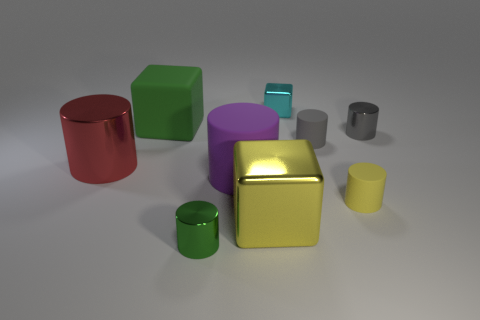Are there the same number of tiny rubber cylinders on the left side of the small yellow rubber cylinder and yellow objects?
Keep it short and to the point. No. What number of other objects are there of the same shape as the big purple matte thing?
Provide a short and direct response. 5. There is a tiny yellow cylinder; what number of big cylinders are right of it?
Your answer should be compact. 0. How big is the matte object that is both in front of the big red thing and to the left of the cyan metal block?
Offer a very short reply. Large. Are there any tiny green balls?
Your answer should be compact. No. What number of other things are there of the same size as the yellow matte cylinder?
Provide a succinct answer. 4. Is the color of the large metal thing behind the yellow shiny thing the same as the metallic thing that is in front of the big metal cube?
Ensure brevity in your answer.  No. There is a gray matte thing that is the same shape as the large purple object; what is its size?
Offer a terse response. Small. Do the yellow object that is left of the tiny block and the cyan thing to the left of the small yellow matte cylinder have the same material?
Give a very brief answer. Yes. What number of rubber things are large purple cylinders or tiny yellow cylinders?
Your answer should be very brief. 2. 